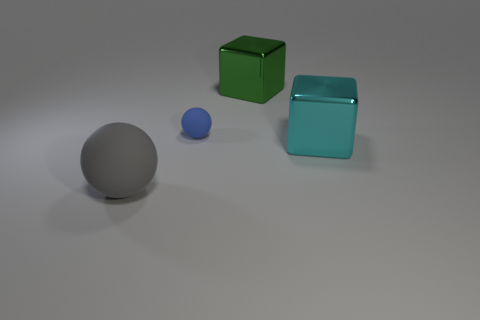Add 1 large cyan things. How many objects exist? 5 Add 3 blue things. How many blue things are left? 4 Add 4 big blue cylinders. How many big blue cylinders exist? 4 Subtract 0 brown cubes. How many objects are left? 4 Subtract all small balls. Subtract all matte things. How many objects are left? 1 